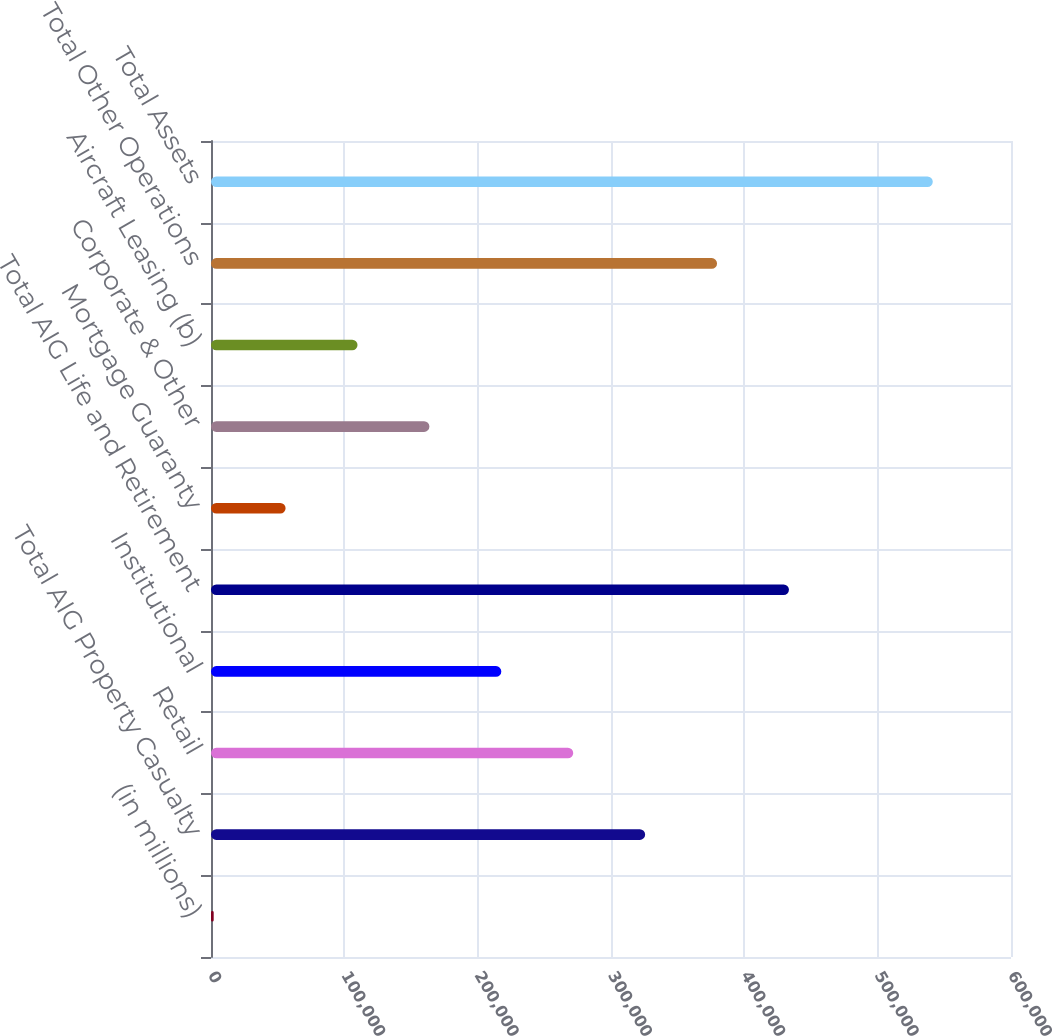Convert chart to OTSL. <chart><loc_0><loc_0><loc_500><loc_500><bar_chart><fcel>(in millions)<fcel>Total AIG Property Casualty<fcel>Retail<fcel>Institutional<fcel>Total AIG Life and Retirement<fcel>Mortgage Guaranty<fcel>Corporate & Other<fcel>Aircraft Leasing (b)<fcel>Total Other Operations<fcel>Total Assets<nl><fcel>2013<fcel>325603<fcel>271671<fcel>217739<fcel>433466<fcel>55944.6<fcel>163808<fcel>109876<fcel>379534<fcel>541329<nl></chart> 